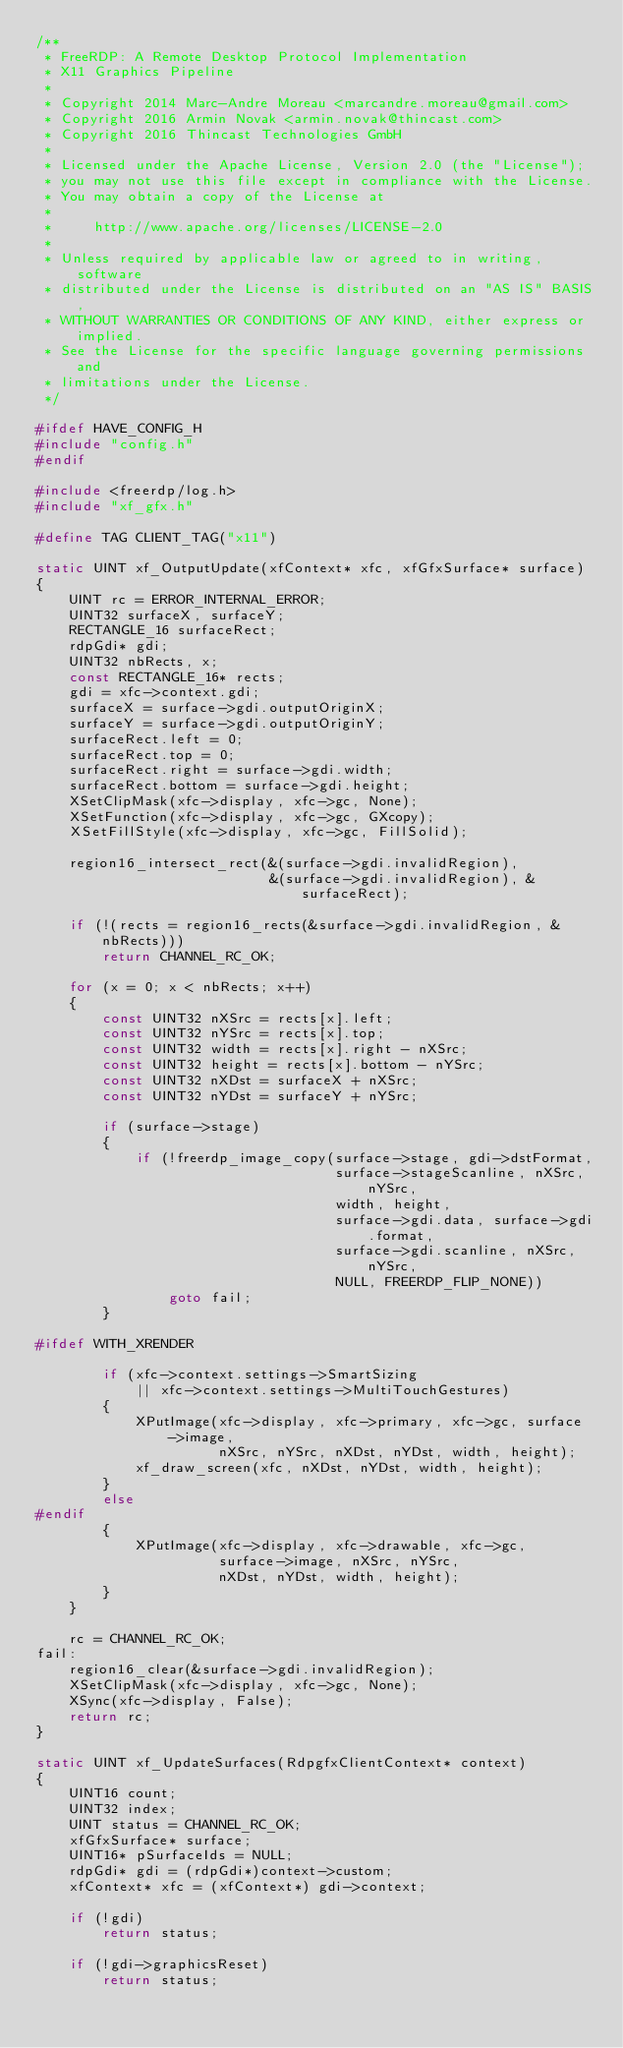Convert code to text. <code><loc_0><loc_0><loc_500><loc_500><_C_>/**
 * FreeRDP: A Remote Desktop Protocol Implementation
 * X11 Graphics Pipeline
 *
 * Copyright 2014 Marc-Andre Moreau <marcandre.moreau@gmail.com>
 * Copyright 2016 Armin Novak <armin.novak@thincast.com>
 * Copyright 2016 Thincast Technologies GmbH
 *
 * Licensed under the Apache License, Version 2.0 (the "License");
 * you may not use this file except in compliance with the License.
 * You may obtain a copy of the License at
 *
 *     http://www.apache.org/licenses/LICENSE-2.0
 *
 * Unless required by applicable law or agreed to in writing, software
 * distributed under the License is distributed on an "AS IS" BASIS,
 * WITHOUT WARRANTIES OR CONDITIONS OF ANY KIND, either express or implied.
 * See the License for the specific language governing permissions and
 * limitations under the License.
 */

#ifdef HAVE_CONFIG_H
#include "config.h"
#endif

#include <freerdp/log.h>
#include "xf_gfx.h"

#define TAG CLIENT_TAG("x11")

static UINT xf_OutputUpdate(xfContext* xfc, xfGfxSurface* surface)
{
	UINT rc = ERROR_INTERNAL_ERROR;
	UINT32 surfaceX, surfaceY;
	RECTANGLE_16 surfaceRect;
	rdpGdi* gdi;
	UINT32 nbRects, x;
	const RECTANGLE_16* rects;
	gdi = xfc->context.gdi;
	surfaceX = surface->gdi.outputOriginX;
	surfaceY = surface->gdi.outputOriginY;
	surfaceRect.left = 0;
	surfaceRect.top = 0;
	surfaceRect.right = surface->gdi.width;
	surfaceRect.bottom = surface->gdi.height;
	XSetClipMask(xfc->display, xfc->gc, None);
	XSetFunction(xfc->display, xfc->gc, GXcopy);
	XSetFillStyle(xfc->display, xfc->gc, FillSolid);

	region16_intersect_rect(&(surface->gdi.invalidRegion),
	                        &(surface->gdi.invalidRegion), &surfaceRect);

	if (!(rects = region16_rects(&surface->gdi.invalidRegion, &nbRects)))
		return CHANNEL_RC_OK;

	for (x = 0; x < nbRects; x++)
	{
		const UINT32 nXSrc = rects[x].left;
		const UINT32 nYSrc = rects[x].top;
		const UINT32 width = rects[x].right - nXSrc;
		const UINT32 height = rects[x].bottom - nYSrc;
		const UINT32 nXDst = surfaceX + nXSrc;
		const UINT32 nYDst = surfaceY + nYSrc;

		if (surface->stage)
		{
			if (!freerdp_image_copy(surface->stage, gdi->dstFormat,
			                        surface->stageScanline, nXSrc, nYSrc,
			                        width, height,
			                        surface->gdi.data, surface->gdi.format,
			                        surface->gdi.scanline, nXSrc, nYSrc,
			                        NULL, FREERDP_FLIP_NONE))
				goto fail;
		}

#ifdef WITH_XRENDER

		if (xfc->context.settings->SmartSizing
		    || xfc->context.settings->MultiTouchGestures)
		{
			XPutImage(xfc->display, xfc->primary, xfc->gc, surface->image,
			          nXSrc, nYSrc, nXDst, nYDst, width, height);
			xf_draw_screen(xfc, nXDst, nYDst, width, height);
		}
		else
#endif
		{
			XPutImage(xfc->display, xfc->drawable, xfc->gc,
			          surface->image, nXSrc, nYSrc,
			          nXDst, nYDst, width, height);
		}
	}

	rc = CHANNEL_RC_OK;
fail:
	region16_clear(&surface->gdi.invalidRegion);
	XSetClipMask(xfc->display, xfc->gc, None);
	XSync(xfc->display, False);
	return rc;
}

static UINT xf_UpdateSurfaces(RdpgfxClientContext* context)
{
	UINT16 count;
	UINT32 index;
	UINT status = CHANNEL_RC_OK;
	xfGfxSurface* surface;
	UINT16* pSurfaceIds = NULL;
	rdpGdi* gdi = (rdpGdi*)context->custom;
	xfContext* xfc = (xfContext*) gdi->context;

	if (!gdi)
		return status;

	if (!gdi->graphicsReset)
		return status;
</code> 